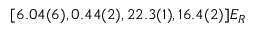<formula> <loc_0><loc_0><loc_500><loc_500>[ 6 . 0 4 ( 6 ) , 0 . 4 4 ( 2 ) , 2 2 . 3 ( 1 ) , 1 6 . 4 ( 2 ) ] E _ { R }</formula> 